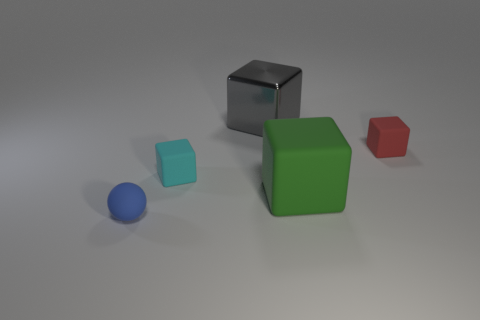Is the number of small blue rubber things less than the number of large blue cylinders?
Offer a very short reply. No. There is a thing that is behind the small thing that is right of the big block that is on the right side of the shiny thing; what is its material?
Your response must be concise. Metal. Is the number of green cubes that are behind the shiny object less than the number of big cyan blocks?
Your answer should be very brief. No. There is a cube that is in front of the cyan rubber cube; does it have the same size as the large gray block?
Provide a succinct answer. Yes. How many tiny cubes are on the left side of the large gray metal thing and right of the gray object?
Your answer should be compact. 0. There is a matte block that is to the right of the big object that is in front of the gray metal block; what is its size?
Your answer should be very brief. Small. Are there fewer large objects that are on the right side of the red cube than cubes to the right of the green rubber object?
Provide a succinct answer. Yes. What is the material of the cube that is both to the right of the small cyan rubber block and left of the green object?
Provide a short and direct response. Metal. Is there a tiny cube?
Your answer should be compact. Yes. What is the shape of the small red thing that is made of the same material as the green block?
Provide a succinct answer. Cube. 